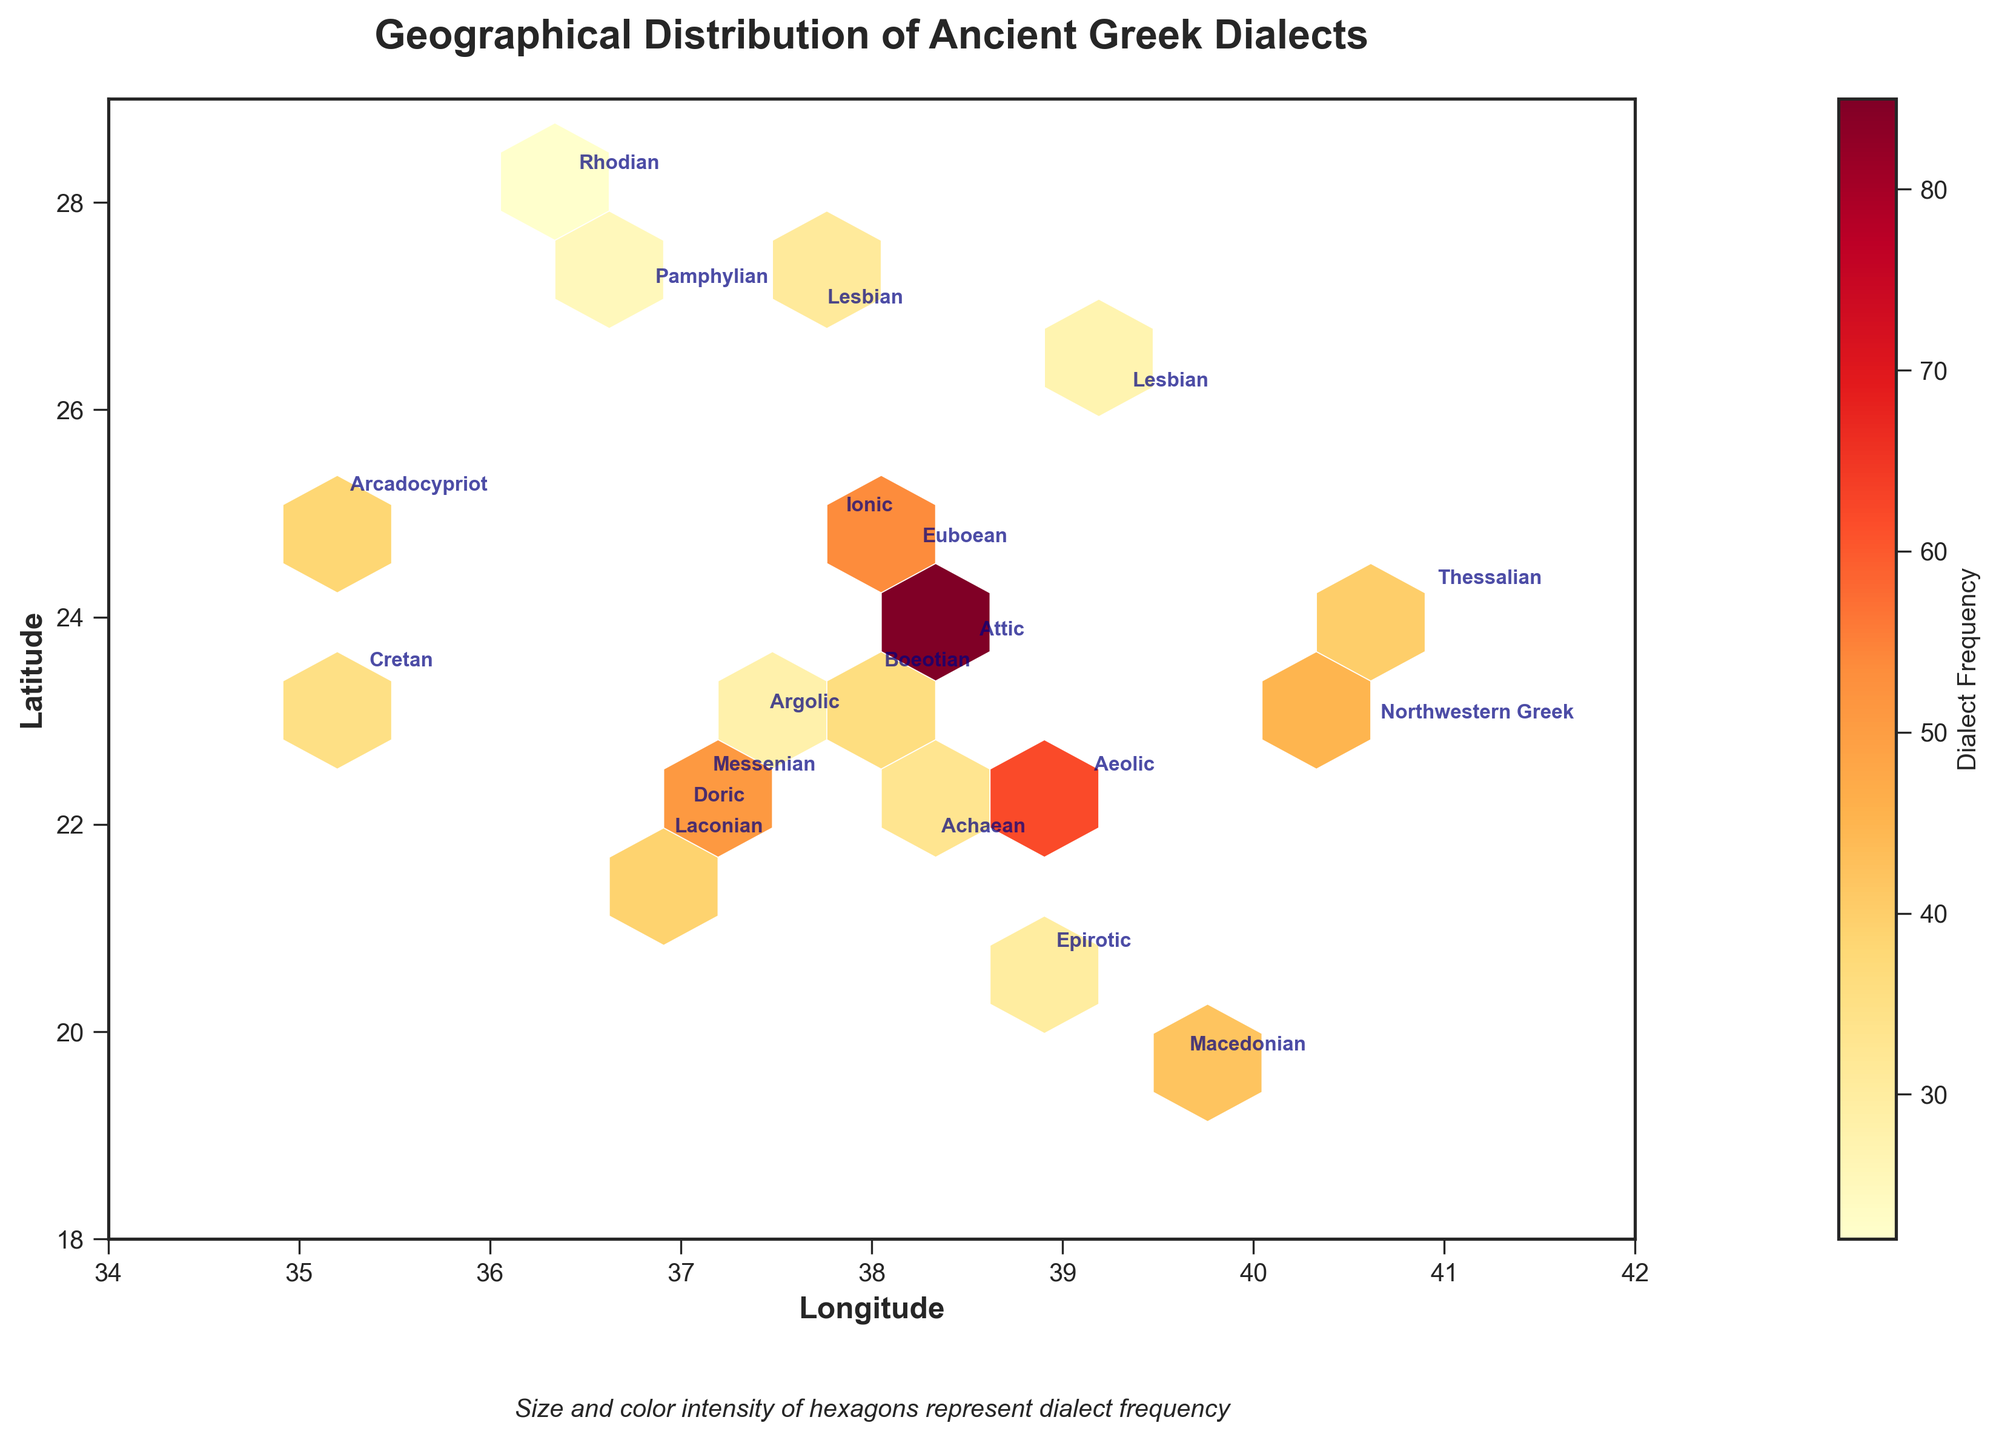What is the title of the plot? The title is displayed at the top of the plot, typically in a larger and bold font to make it stand out.
Answer: Geographical Distribution of Ancient Greek Dialects What do the hexagons represent in the plot? Hexagons represent aggregated data points, with their size and color intensity indicating the frequency of dialects in those geographical areas.
Answer: Aggregated data points with frequency Which dialect appears the most frequently in the central region of the plot? By looking at the central region around coordinates (37, 23), the Attic dialect is annotated and represented by a prominent hexagon with a high frequency.
Answer: Attic Which area has the most intense color hexagon and what dialect does it represent? The most intense color hexagon is the one with the deepest shade of red, representing the highest frequency. By comparing annotations and locations, the hexagon around (38.5, 23.7) represents the Attic dialect.
Answer: Around  (38.5, 23.7), Attic What are the longitude and latitude ranges displayed on the plot? The axes on the plot usually mark the minimum and maximum values covered. By examining the plots, the longitude range is from 34 to 42 and the latitude range is from 18 to 29.
Answer: Longitude: 34 to 42, Latitude: 18 to 29 Which dialects are geographically closest to (39, 22)? By locating (39, 22) on the plot and checking nearby annotations, the dialects close to these coordinates are Aeolic and Attic.
Answer: Aeolic and Attic How many different dialects are represented in the hexbin plot? Counting the number of unique annotations on the plot, we identify the number of distinct dialects.
Answer: 16 Which dialects appear in the northernmost and southernmost locations? By identifying the topmost and bottommost annotations on the plot, we determine that the northernmost dialect is Thessalian around (40.9, 24.2), and the southernmost one is Cretan around (35.3, 23.4).
Answer: Northernmost: Thessalian, Southernmost: Cretan What is the frequency of the Ionic dialect? Locate the annotation for the Ionic dialect around (37.8, 24.9) and refer to the frequency value in its vicinity.
Answer: 78 Compare the frequencies of the Attic and Doric dialects. Which one is higher and by how much? Find the frequencies for Attic (85) and Doric (70) respectively, then subtract the lower value from the higher one.
Answer: Attic is higher by 15 